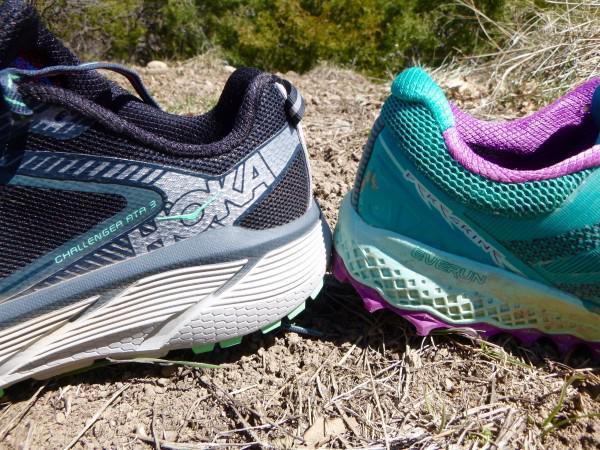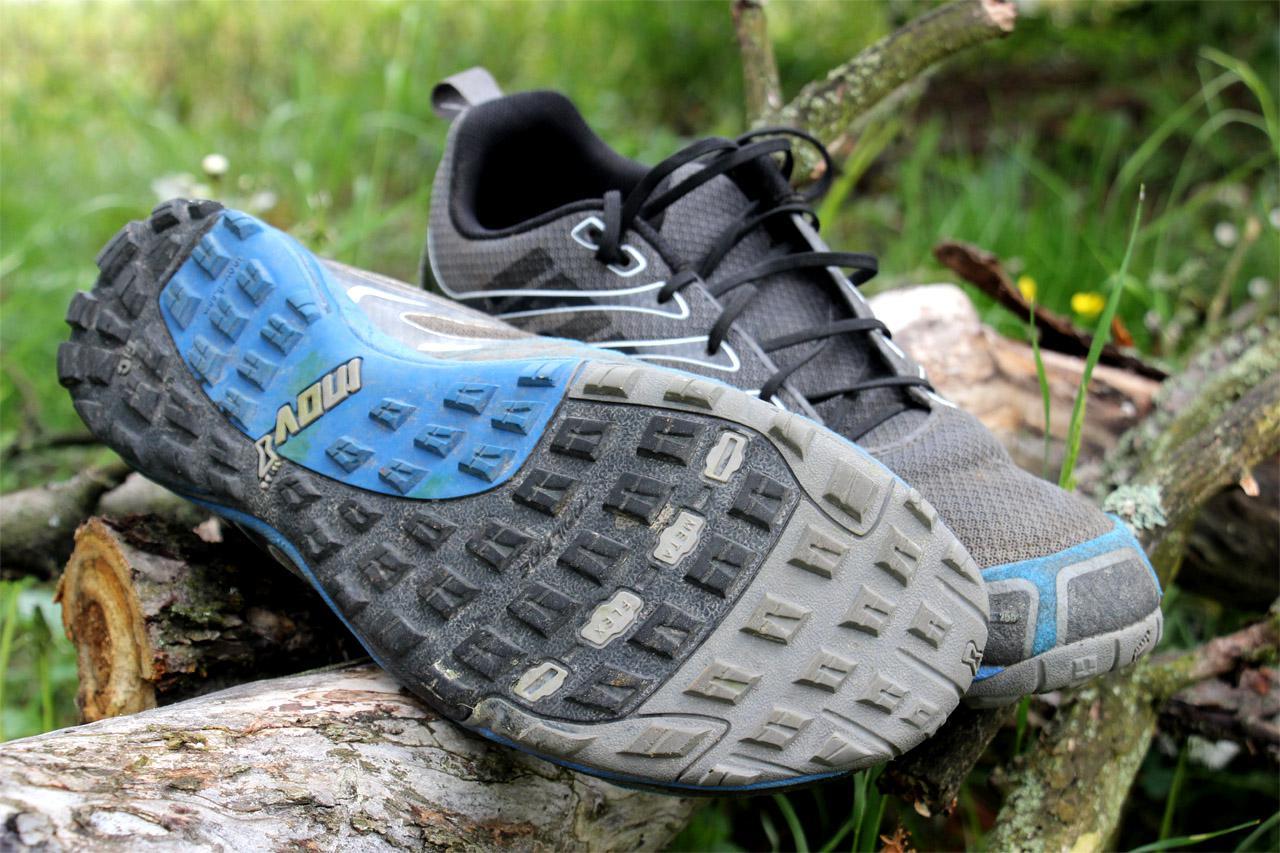The first image is the image on the left, the second image is the image on the right. Analyze the images presented: Is the assertion "The shoes in the left image are facing opposite each other." valid? Answer yes or no. Yes. The first image is the image on the left, the second image is the image on the right. Given the left and right images, does the statement "shoes are placed heel to heel" hold true? Answer yes or no. Yes. 